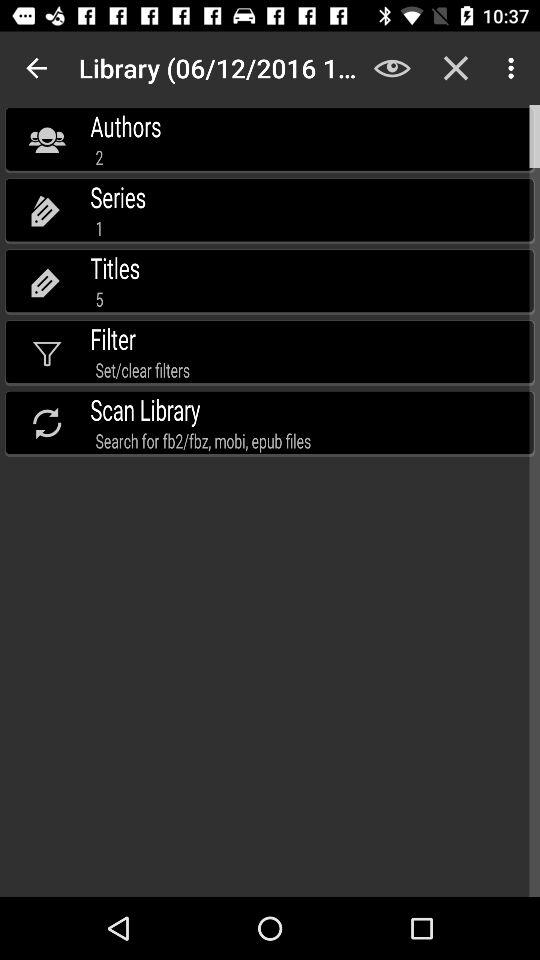What is the total number of series? The total number of series is 1. 